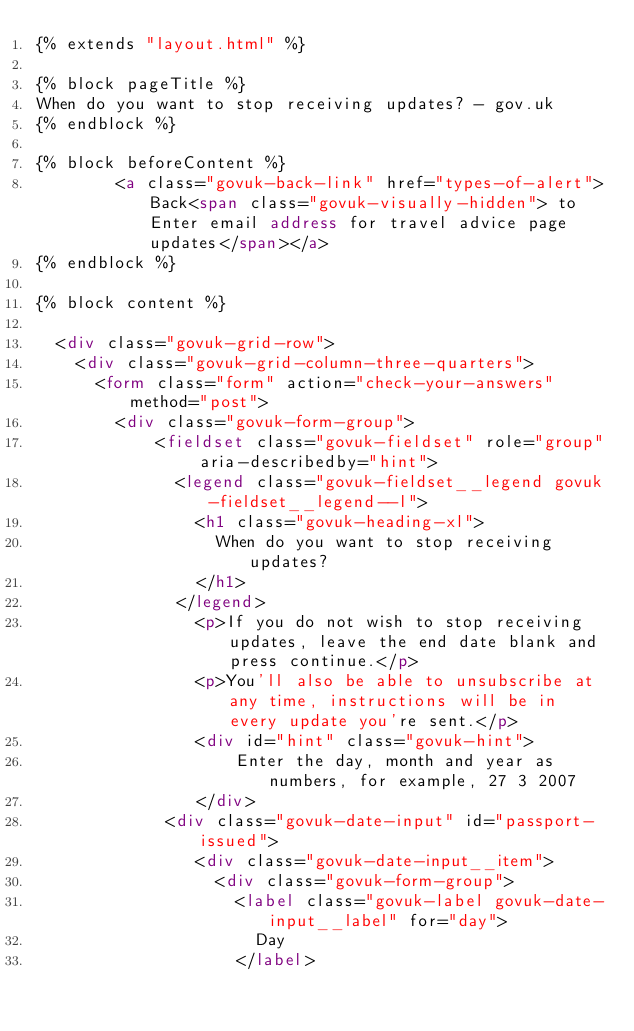Convert code to text. <code><loc_0><loc_0><loc_500><loc_500><_HTML_>{% extends "layout.html" %}

{% block pageTitle %}
When do you want to stop receiving updates? - gov.uk
{% endblock %}

{% block beforeContent %}
        <a class="govuk-back-link" href="types-of-alert">Back<span class="govuk-visually-hidden"> to Enter email address for travel advice page updates</span></a>
{% endblock %}

{% block content %}

  <div class="govuk-grid-row">
    <div class="govuk-grid-column-three-quarters">
      <form class="form" action="check-your-answers" method="post">
        <div class="govuk-form-group">
            <fieldset class="govuk-fieldset" role="group" aria-describedby="hint">
              <legend class="govuk-fieldset__legend govuk-fieldset__legend--l">
                <h1 class="govuk-heading-xl">
                  When do you want to stop receiving updates?
                </h1>
              </legend>
				<p>If you do not wish to stop receiving updates, leave the end date blank and press continue.</p>
				<p>You'll also be able to unsubscribe at any time, instructions will be in every update you're sent.</p>
				<div id="hint" class="govuk-hint">
					Enter the day, month and year as numbers, for example, 27 3 2007
				</div>
             <div class="govuk-date-input" id="passport-issued">
                <div class="govuk-date-input__item">
                  <div class="govuk-form-group">
                    <label class="govuk-label govuk-date-input__label" for="day">
                      Day
                    </label></code> 